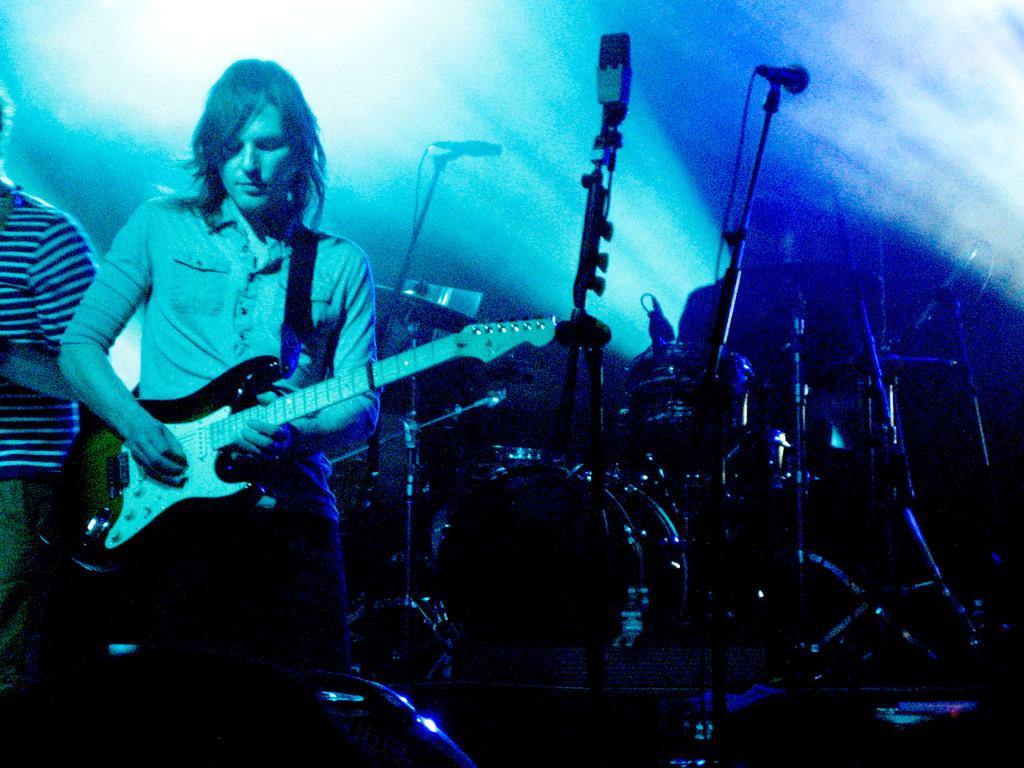What is the man in the image doing? The man is playing a guitar in the image. What other objects related to music can be seen in the image? There are musical instruments and a microphone (mike) in the image. What type of cake is being served at the concert in the image? There is no cake present in the image, and the image does not depict a concert. 